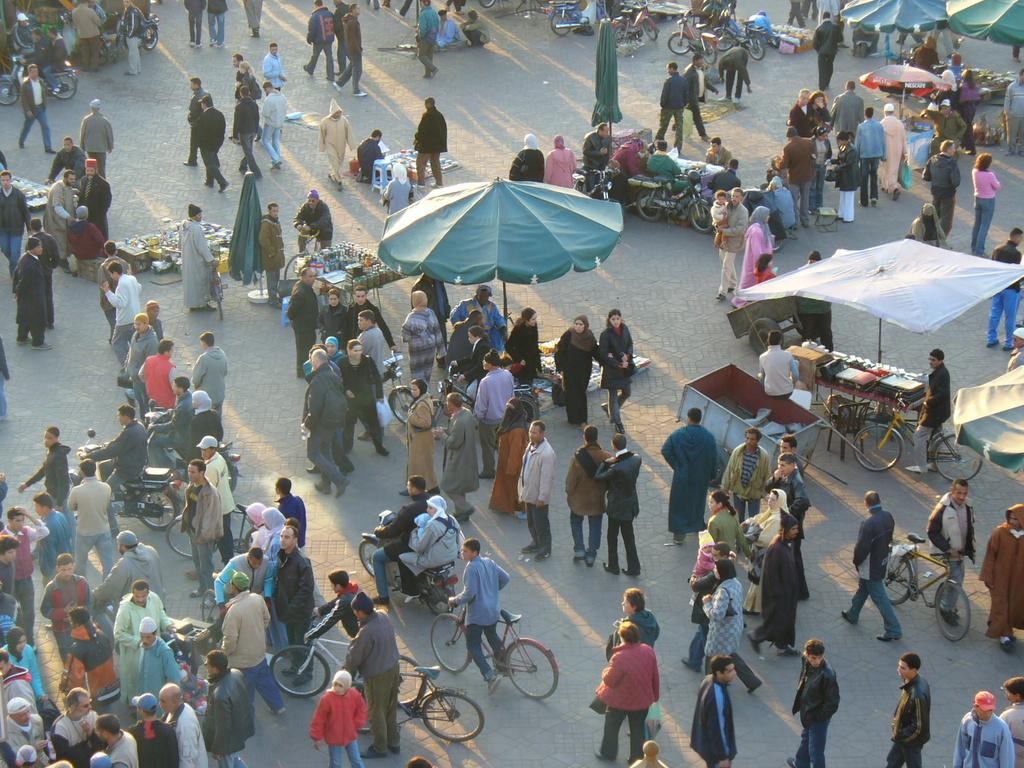What type of location is depicted in the image? There is a market in the image. How many stalls can be seen in the market? There are many stalls in the market. What are the people in the image doing? People are walking around the stalls. What else is moving around the stalls in the image? Vehicles are moving around the stalls. What type of agreement is being signed by the toy team in the image? There is no toy team or agreement present in the image; it depicts a market with stalls, people, and vehicles. 